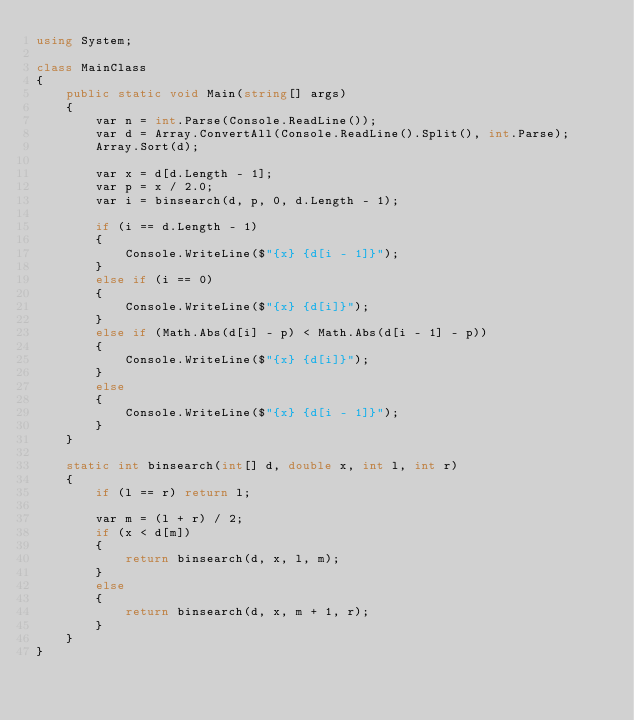Convert code to text. <code><loc_0><loc_0><loc_500><loc_500><_C#_>using System;

class MainClass
{
    public static void Main(string[] args)
    {
        var n = int.Parse(Console.ReadLine());
        var d = Array.ConvertAll(Console.ReadLine().Split(), int.Parse);
        Array.Sort(d);

        var x = d[d.Length - 1];
        var p = x / 2.0;
        var i = binsearch(d, p, 0, d.Length - 1);

        if (i == d.Length - 1)
        {
            Console.WriteLine($"{x} {d[i - 1]}");
        }
        else if (i == 0)
        {
            Console.WriteLine($"{x} {d[i]}");
        }
        else if (Math.Abs(d[i] - p) < Math.Abs(d[i - 1] - p))
        {
            Console.WriteLine($"{x} {d[i]}");
        }
        else
        {
            Console.WriteLine($"{x} {d[i - 1]}");
        }
    }

    static int binsearch(int[] d, double x, int l, int r)
    {
        if (l == r) return l;

        var m = (l + r) / 2;
        if (x < d[m])
        {
            return binsearch(d, x, l, m);
        }
        else
        {
            return binsearch(d, x, m + 1, r);
        }
    }
}
</code> 